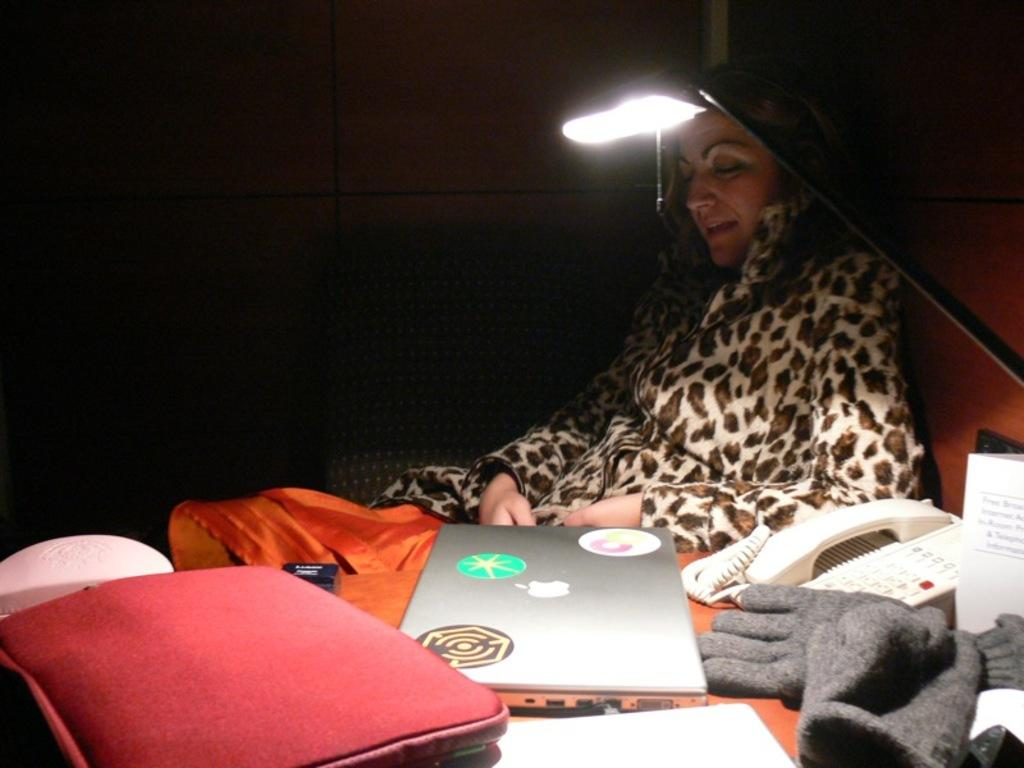What is the woman doing in the image? The woman is sitting on a chair in the image. What objects are on the table in the image? There is a lamp, a laptop, a telephone, gloves, a paper, and other objects on the table. What can be seen in the background of the image? A wall is visible in the background of the image. What is the woman possibly using on the table? The woman might be using the laptop and telephone on the table. Is there a horse in the image? No, there is no horse present in the image. What type of chicken is sitting on the woman's lap in the image? There is no chicken present in the image; the woman is sitting on a chair with various objects on the table. 